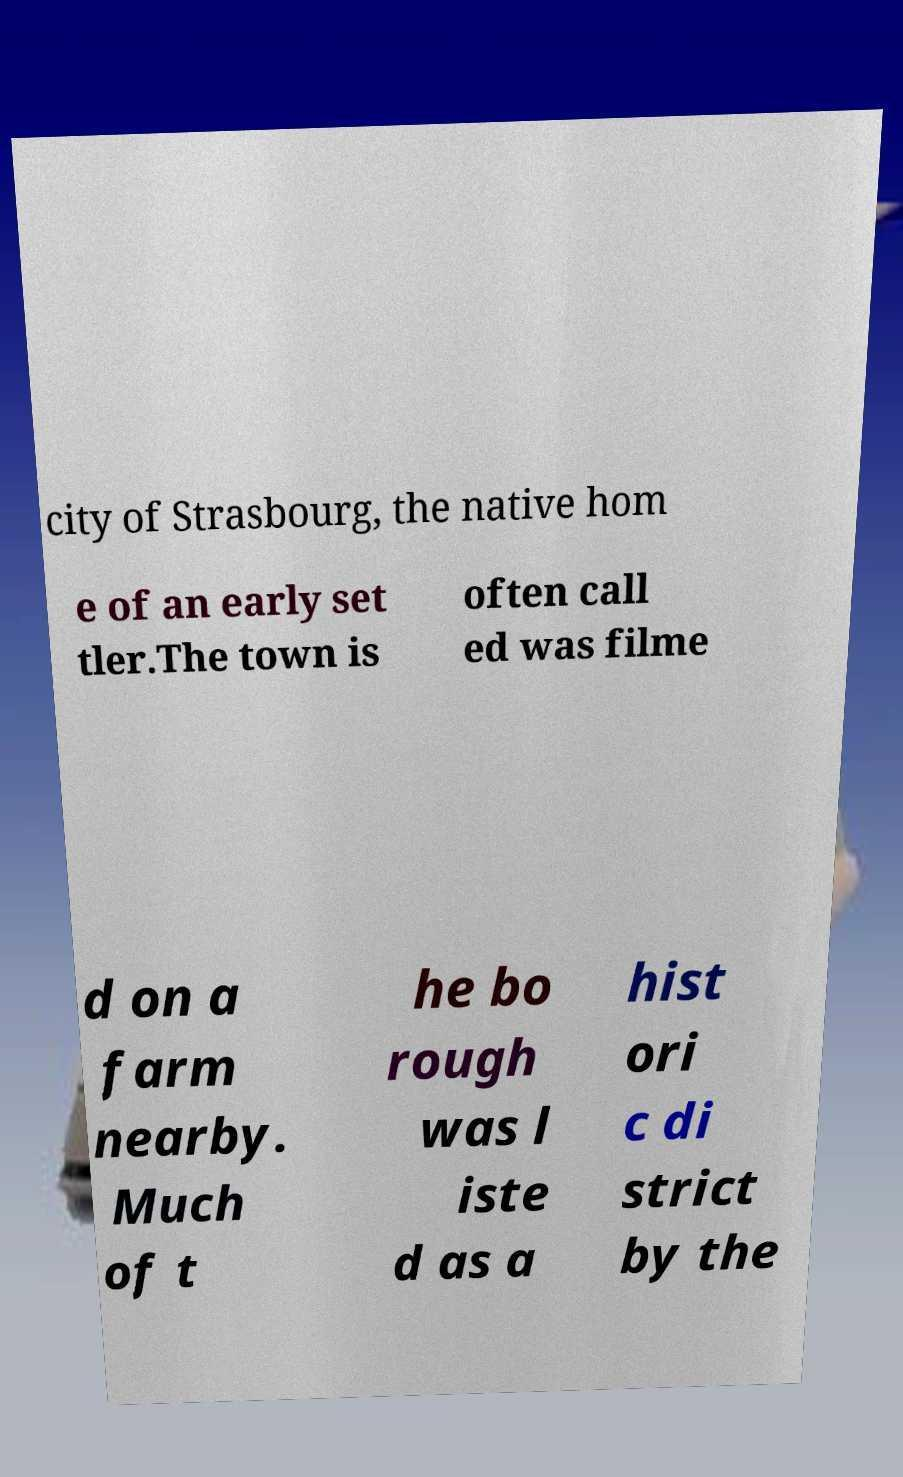Can you accurately transcribe the text from the provided image for me? city of Strasbourg, the native hom e of an early set tler.The town is often call ed was filme d on a farm nearby. Much of t he bo rough was l iste d as a hist ori c di strict by the 